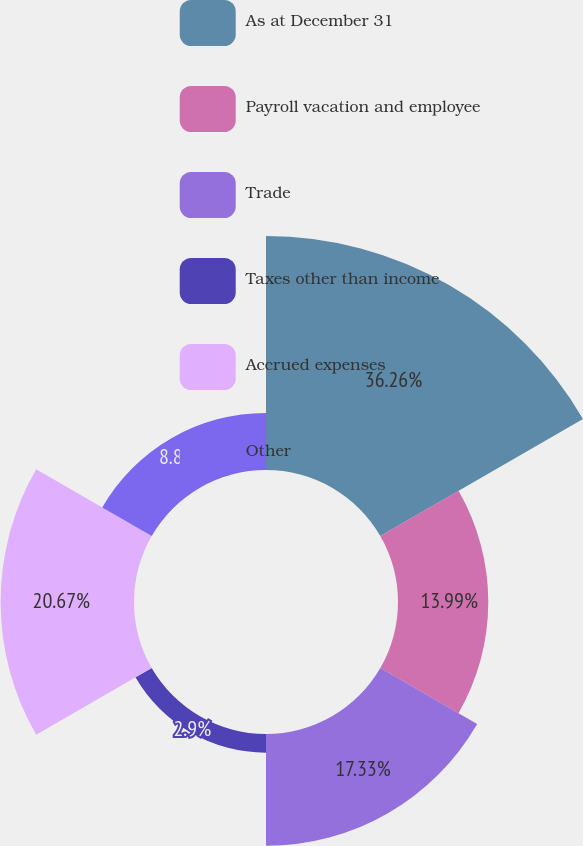Convert chart. <chart><loc_0><loc_0><loc_500><loc_500><pie_chart><fcel>As at December 31<fcel>Payroll vacation and employee<fcel>Trade<fcel>Taxes other than income<fcel>Accrued expenses<fcel>Other<nl><fcel>36.26%<fcel>13.99%<fcel>17.33%<fcel>2.9%<fcel>20.67%<fcel>8.85%<nl></chart> 